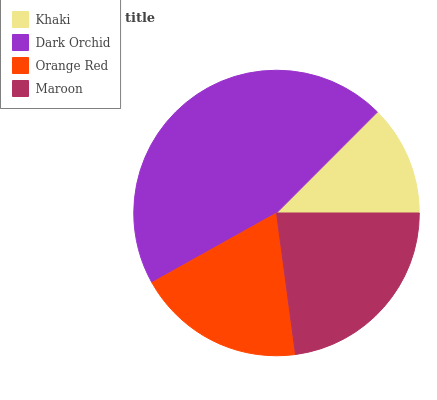Is Khaki the minimum?
Answer yes or no. Yes. Is Dark Orchid the maximum?
Answer yes or no. Yes. Is Orange Red the minimum?
Answer yes or no. No. Is Orange Red the maximum?
Answer yes or no. No. Is Dark Orchid greater than Orange Red?
Answer yes or no. Yes. Is Orange Red less than Dark Orchid?
Answer yes or no. Yes. Is Orange Red greater than Dark Orchid?
Answer yes or no. No. Is Dark Orchid less than Orange Red?
Answer yes or no. No. Is Maroon the high median?
Answer yes or no. Yes. Is Orange Red the low median?
Answer yes or no. Yes. Is Orange Red the high median?
Answer yes or no. No. Is Dark Orchid the low median?
Answer yes or no. No. 